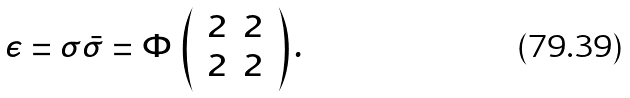Convert formula to latex. <formula><loc_0><loc_0><loc_500><loc_500>\epsilon = \sigma \bar { \sigma } = \Phi \, \left ( \, \begin{array} { c c } { 2 } & { 2 } \\ { 2 } & { 2 } \end{array} \, \right ) .</formula> 